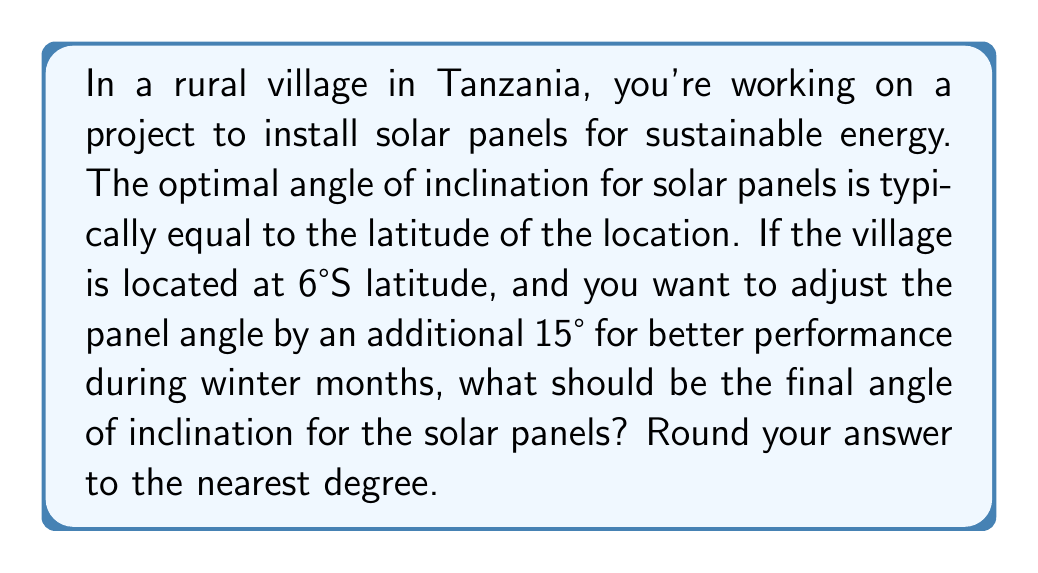Help me with this question. To solve this problem, we need to follow these steps:

1. Determine the base angle:
   The optimal angle of inclination is typically equal to the latitude of the location. In this case, the village is at 6°S latitude.
   
   Base angle = $|6°|$ (We take the absolute value since we're only concerned with the magnitude)

2. Add the adjustment for winter months:
   We need to add an additional 15° to the base angle for better performance during winter.
   
   Adjustment = $15°$

3. Calculate the final angle:
   Final angle = Base angle + Adjustment
   $$ \text{Final angle} = 6° + 15° = 21° $$

4. Round to the nearest degree:
   The result is already a whole number, so no rounding is necessary.

[asy]
import geometry;

size(200);
draw((0,0)--(100,0), arrow=Arrow(TeXHead));
draw((0,0)--(0,100), arrow=Arrow(TeXHead));
draw((0,0)--(100,38.4), arrow=Arrow(TeXHead));

label("Ground", (50,-10));
label("Vertical", (-10,50));
label("Solar Panel", (70,25));

draw(arc((0,0),20,0,21), arrow=Arrow(TeXHead));
label("21°", (15,8));
[/asy]

The diagram above illustrates the final angle of inclination for the solar panel.
Answer: $21°$ 